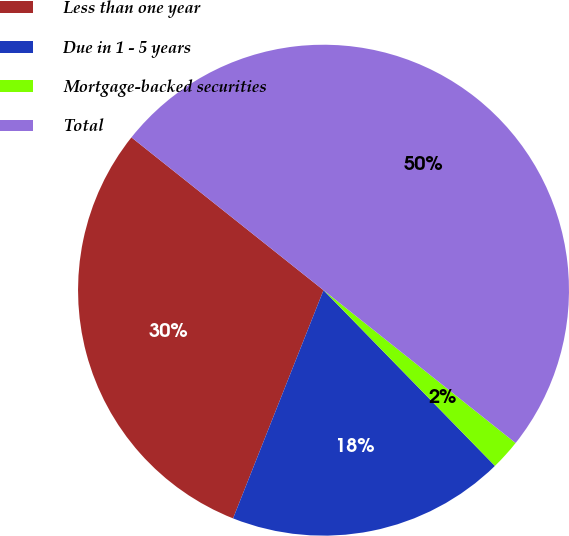Convert chart to OTSL. <chart><loc_0><loc_0><loc_500><loc_500><pie_chart><fcel>Less than one year<fcel>Due in 1 - 5 years<fcel>Mortgage-backed securities<fcel>Total<nl><fcel>29.69%<fcel>18.31%<fcel>2.0%<fcel>50.0%<nl></chart> 